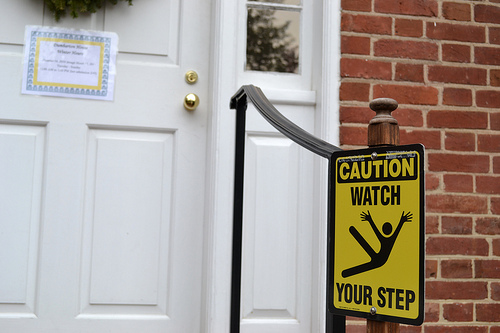<image>
Is the sign on the railing? Yes. Looking at the image, I can see the sign is positioned on top of the railing, with the railing providing support. Is there a sign board to the left of the door? Yes. From this viewpoint, the sign board is positioned to the left side relative to the door. 